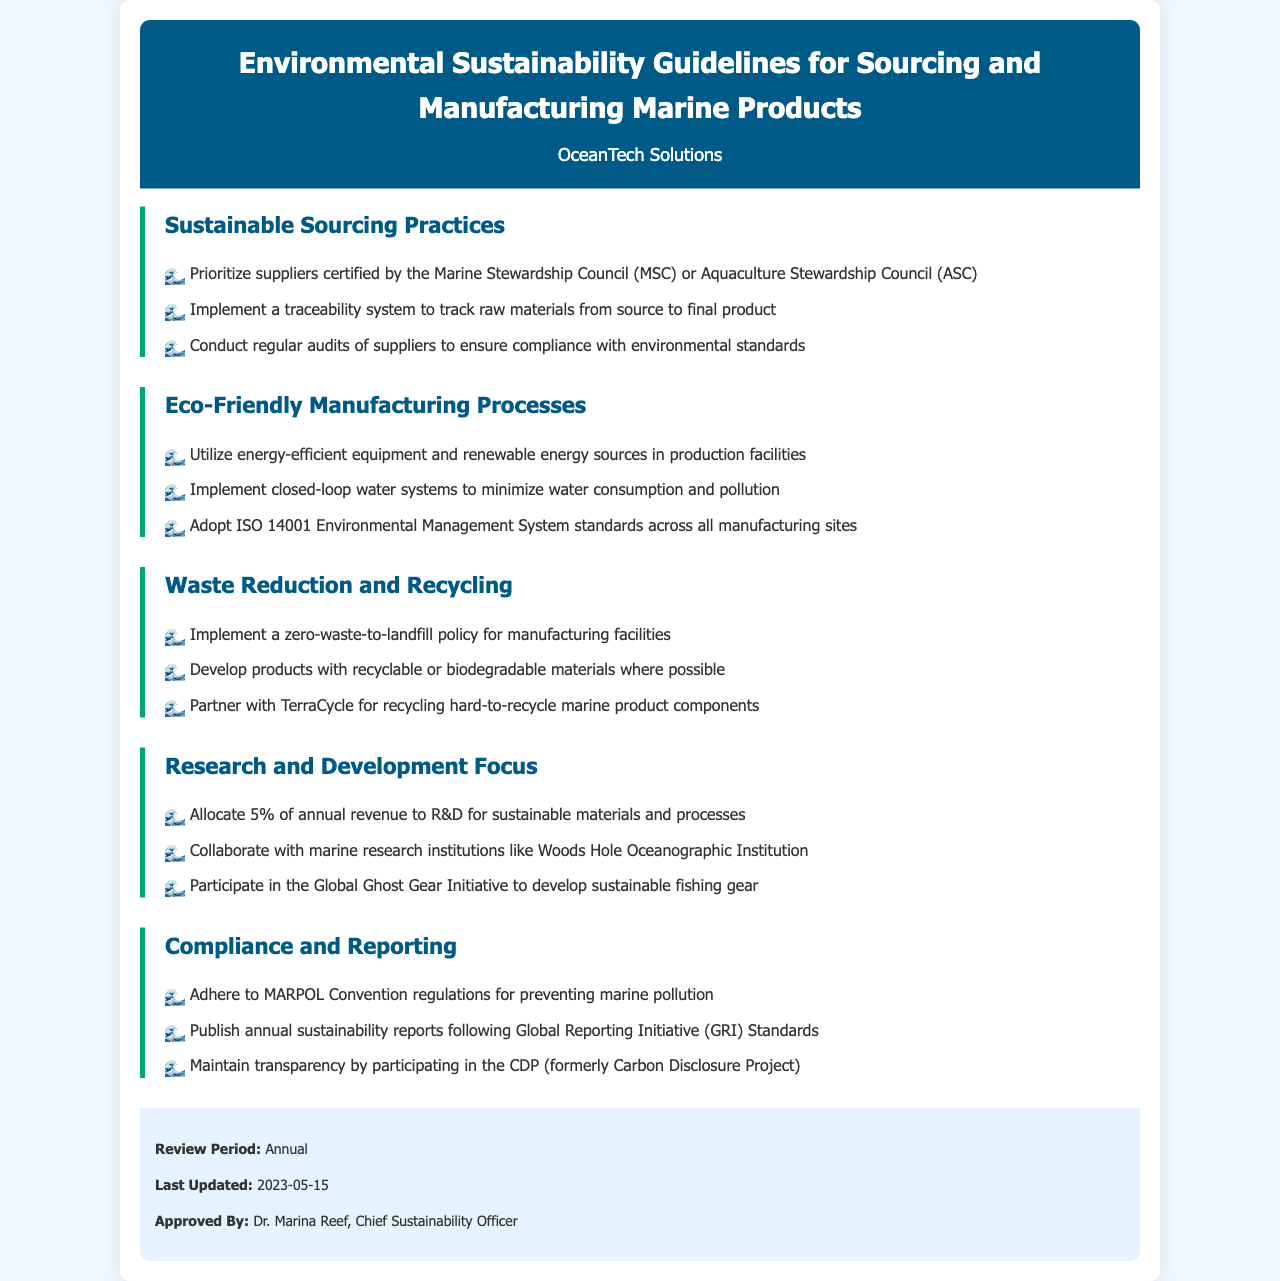What are the certifications prioritized for suppliers? The document specifies that suppliers certified by the Marine Stewardship Council (MSC) or Aquaculture Stewardship Council (ASC) should be prioritized.
Answer: MSC or ASC What percentage of annual revenue is allocated to R&D? The document states that 5% of annual revenue is allocated to research and development for sustainable materials and processes.
Answer: 5% Who is the Chief Sustainability Officer? The document lists Dr. Marina Reef as the Chief Sustainability Officer who approved the guidelines.
Answer: Dr. Marina Reef What is the focus of the Research and Development section? This section emphasizes the allocation of revenue for sustainable materials and collaboration with marine research institutions.
Answer: Sustainable materials and processes When was the last update of the document? The document mentions that the last update occurred on May 15, 2023.
Answer: 2023-05-15 What is the zero-waste policy concerning? The document states that there should be a zero-waste-to-landfill policy for manufacturing facilities.
Answer: Zero-waste-to-landfill What environmental management standard is adopted across manufacturing sites? The guidelines indicate that ISO 14001 Environmental Management System standards are adopted across all manufacturing sites.
Answer: ISO 14001 Which organization is partnered with for recycling hard-to-recycle components? The document mentions partnering with TerraCycle for recycling hard-to-recycle marine product components.
Answer: TerraCycle 